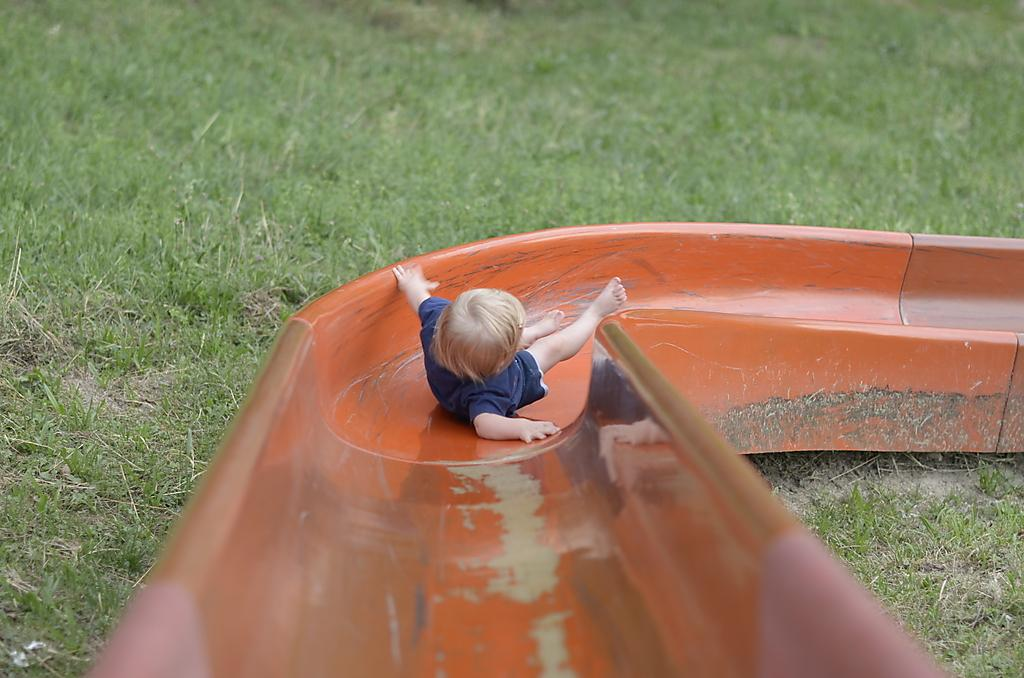What type of surface is visible in the image? There is grass in the image. What can be found on the grass in the image? There is playground equipment in the image. What is the color of the playground equipment? The playground equipment is orange in color. Who is using the playground equipment? A child is on the playground equipment. What color are the child's clothes? The child is wearing blue clothes. Reasoning: Let' Let's think step by step in order to produce the conversation. We start by identifying the main surface in the image, which is the grass. Then, we describe the playground equipment, including its color and the fact that it is being used by a child. Finally, we mention the child's clothing color. Each question is designed to elicit a specific detail about the image that is known from the provided facts. Absurd Question/Answer: How many rings are visible on the child's fingers in the image? There are no rings visible on the child's fingers in the image. What type of loaf is being used as a seat on the playground equipment? There is no loaf present in the image; the playground equipment is designed for children to sit on. 